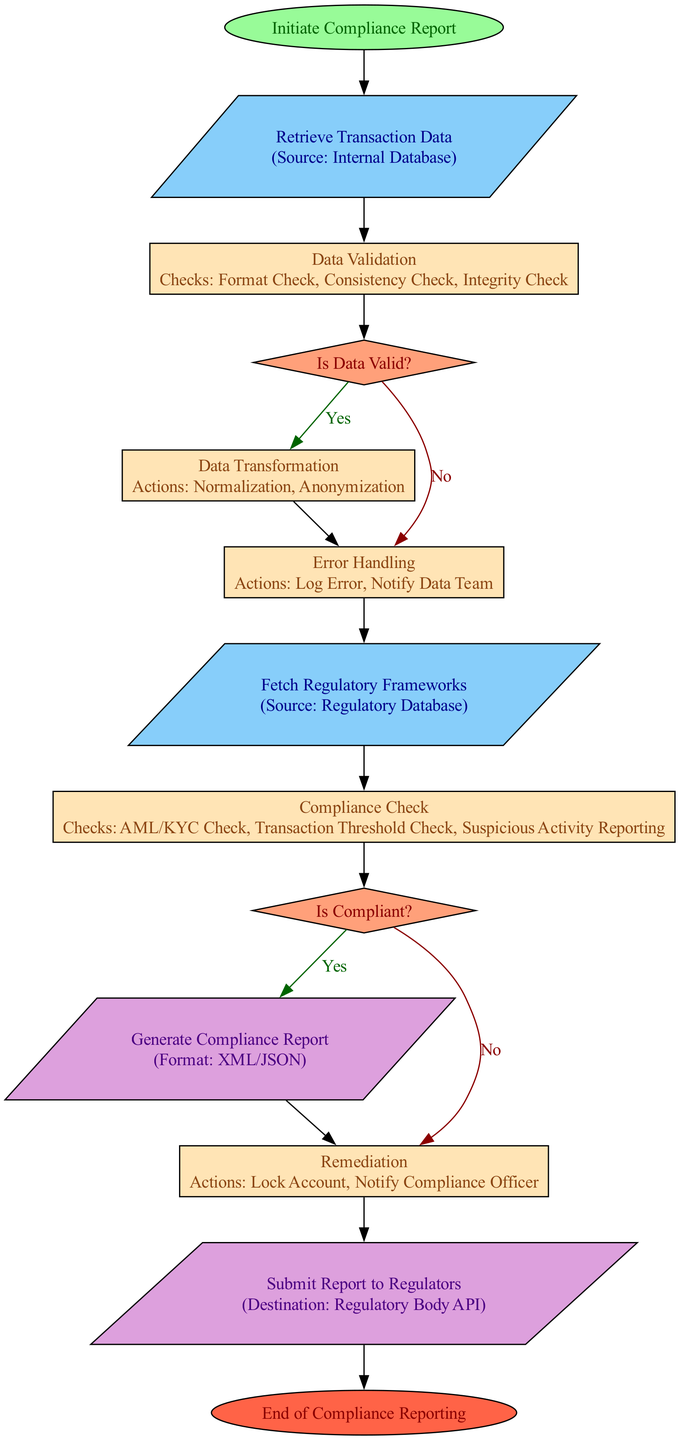What is the first step in the compliance reporting pipeline? The first step in the diagram is labeled "Initiate Compliance Report." This is clearly indicated as the starting node of the flow chart.
Answer: Initiate Compliance Report How many decision points are present in the diagram? The diagram includes two decision nodes: "Is Data Valid?" and "Is Compliant?" By counting them, we find there are a total of two decision points.
Answer: 2 What happens if the data is invalid? If the data is invalid, the flow moves to the "Error Handling" process, which includes logging the error and notifying the data team. This is specified as the action taken when the answer to the decision "Is Data Valid?" is "no."
Answer: Error Handling Which step follows the "Compliance Check" process? After the "Compliance Check," the next decision node is "Is Compliant?" This indicates the flow continues to evaluate compliance after checking regulatory frameworks.
Answer: Is Compliant? What format is the compliance report generated in? The compliance report is generated in either XML or JSON format, as indicated in the "Generate Compliance Report" process.
Answer: XML/JSON What actions are taken during the "Remediation" process? During the "Remediation" process, the actions taken are to lock the account and notify the compliance officer. This information is clearly outlined under this process node.
Answer: Lock Account, Notify Compliance Officer What is the last step before reaching the end of compliance reporting? The last step before the end is "Submit Report to Regulators," which shows that the compliance report is submitted to the regulatory body’s API. This step occurs just before reaching the end node.
Answer: Submit Report to Regulators How many processes are there in total? Throughout the flow chart, the processes include "Data Validation," "Data Transformation," "Error Handling," "Compliance Check," "Generate Compliance Report," "Remediation," and "Submit Report to Regulators." By counting these, we find there are seven processes in total.
Answer: 7 